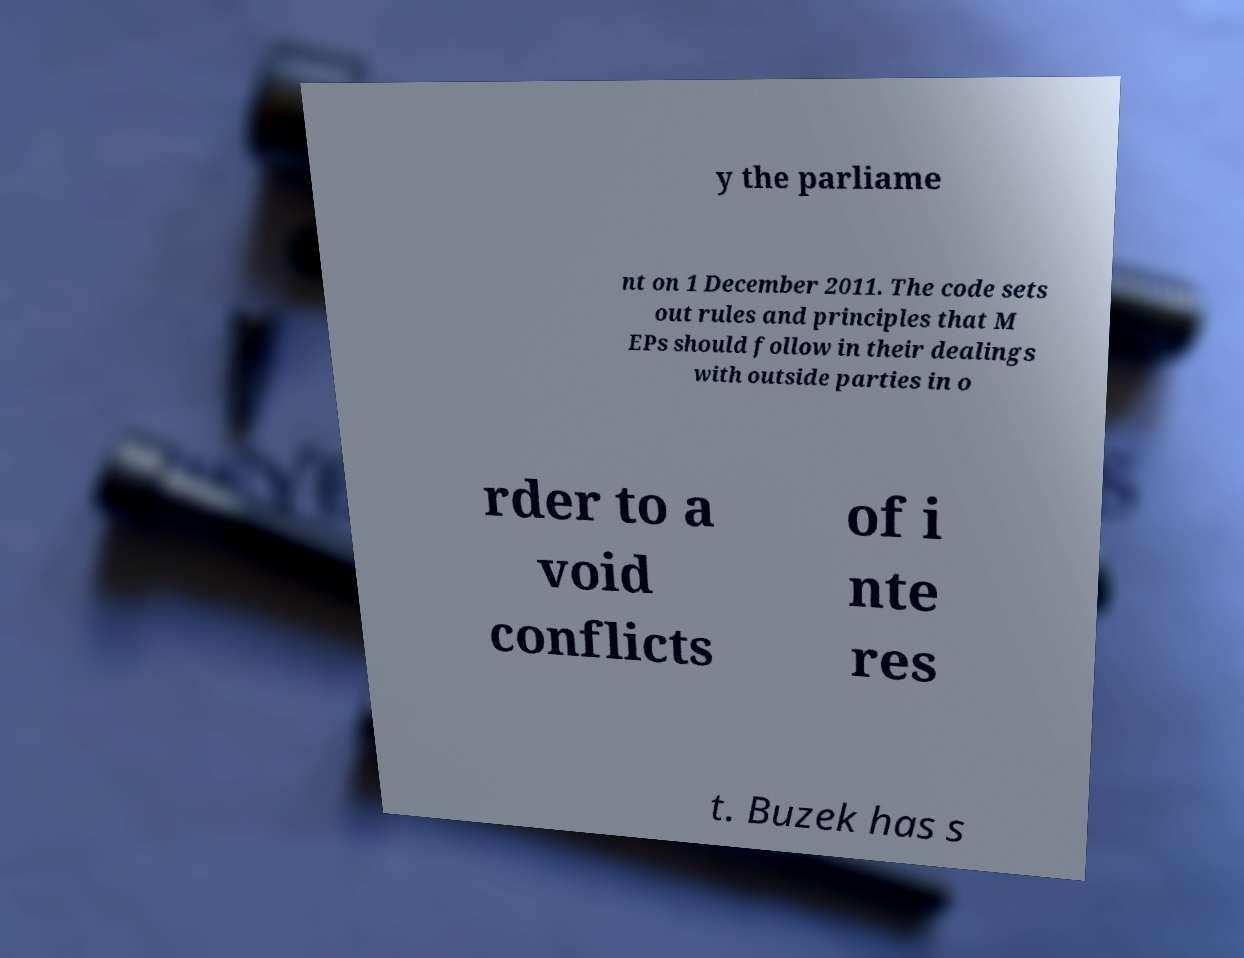Can you accurately transcribe the text from the provided image for me? y the parliame nt on 1 December 2011. The code sets out rules and principles that M EPs should follow in their dealings with outside parties in o rder to a void conflicts of i nte res t. Buzek has s 